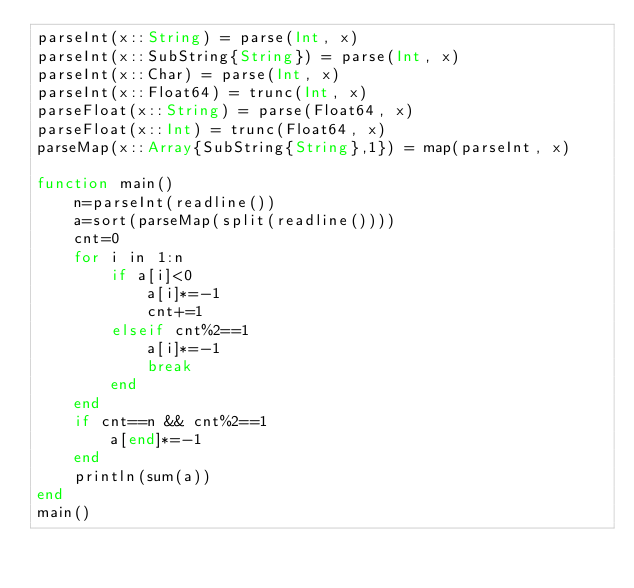Convert code to text. <code><loc_0><loc_0><loc_500><loc_500><_Julia_>parseInt(x::String) = parse(Int, x)
parseInt(x::SubString{String}) = parse(Int, x)
parseInt(x::Char) = parse(Int, x)
parseInt(x::Float64) = trunc(Int, x)
parseFloat(x::String) = parse(Float64, x)
parseFloat(x::Int) = trunc(Float64, x)
parseMap(x::Array{SubString{String},1}) = map(parseInt, x)

function main()
    n=parseInt(readline())
    a=sort(parseMap(split(readline())))
    cnt=0
    for i in 1:n
        if a[i]<0
            a[i]*=-1
            cnt+=1
        elseif cnt%2==1
            a[i]*=-1
            break
        end
    end
    if cnt==n && cnt%2==1
        a[end]*=-1
    end
    println(sum(a))
end
main()</code> 